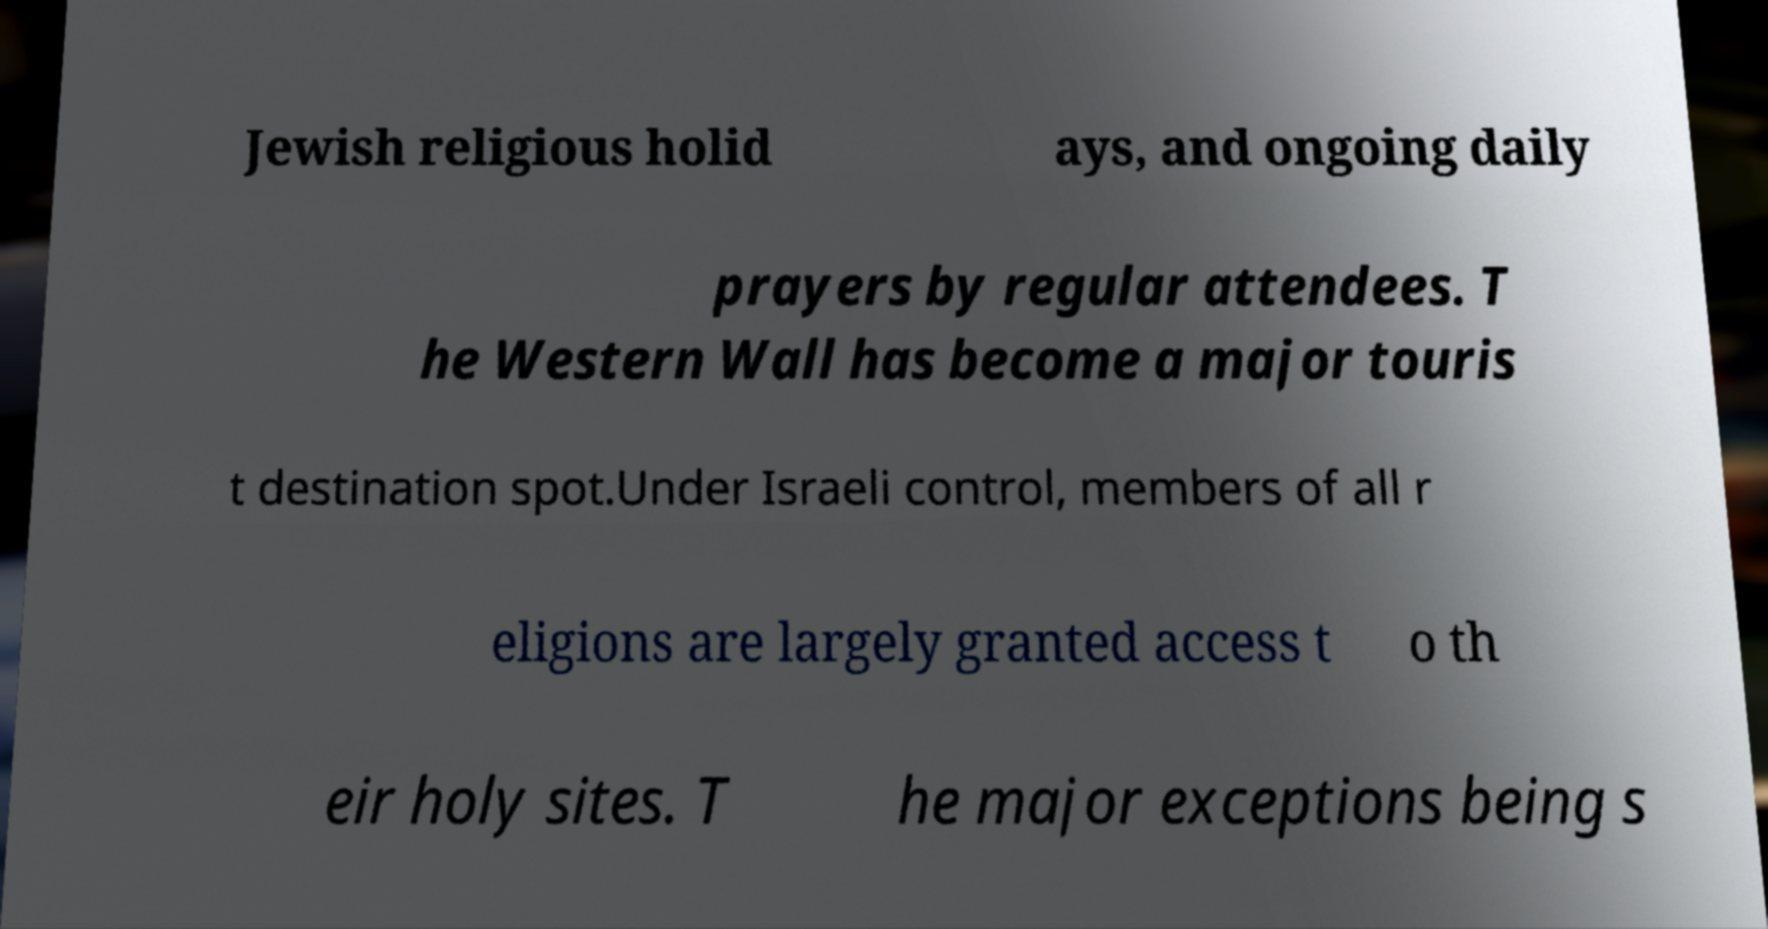Could you assist in decoding the text presented in this image and type it out clearly? Jewish religious holid ays, and ongoing daily prayers by regular attendees. T he Western Wall has become a major touris t destination spot.Under Israeli control, members of all r eligions are largely granted access t o th eir holy sites. T he major exceptions being s 